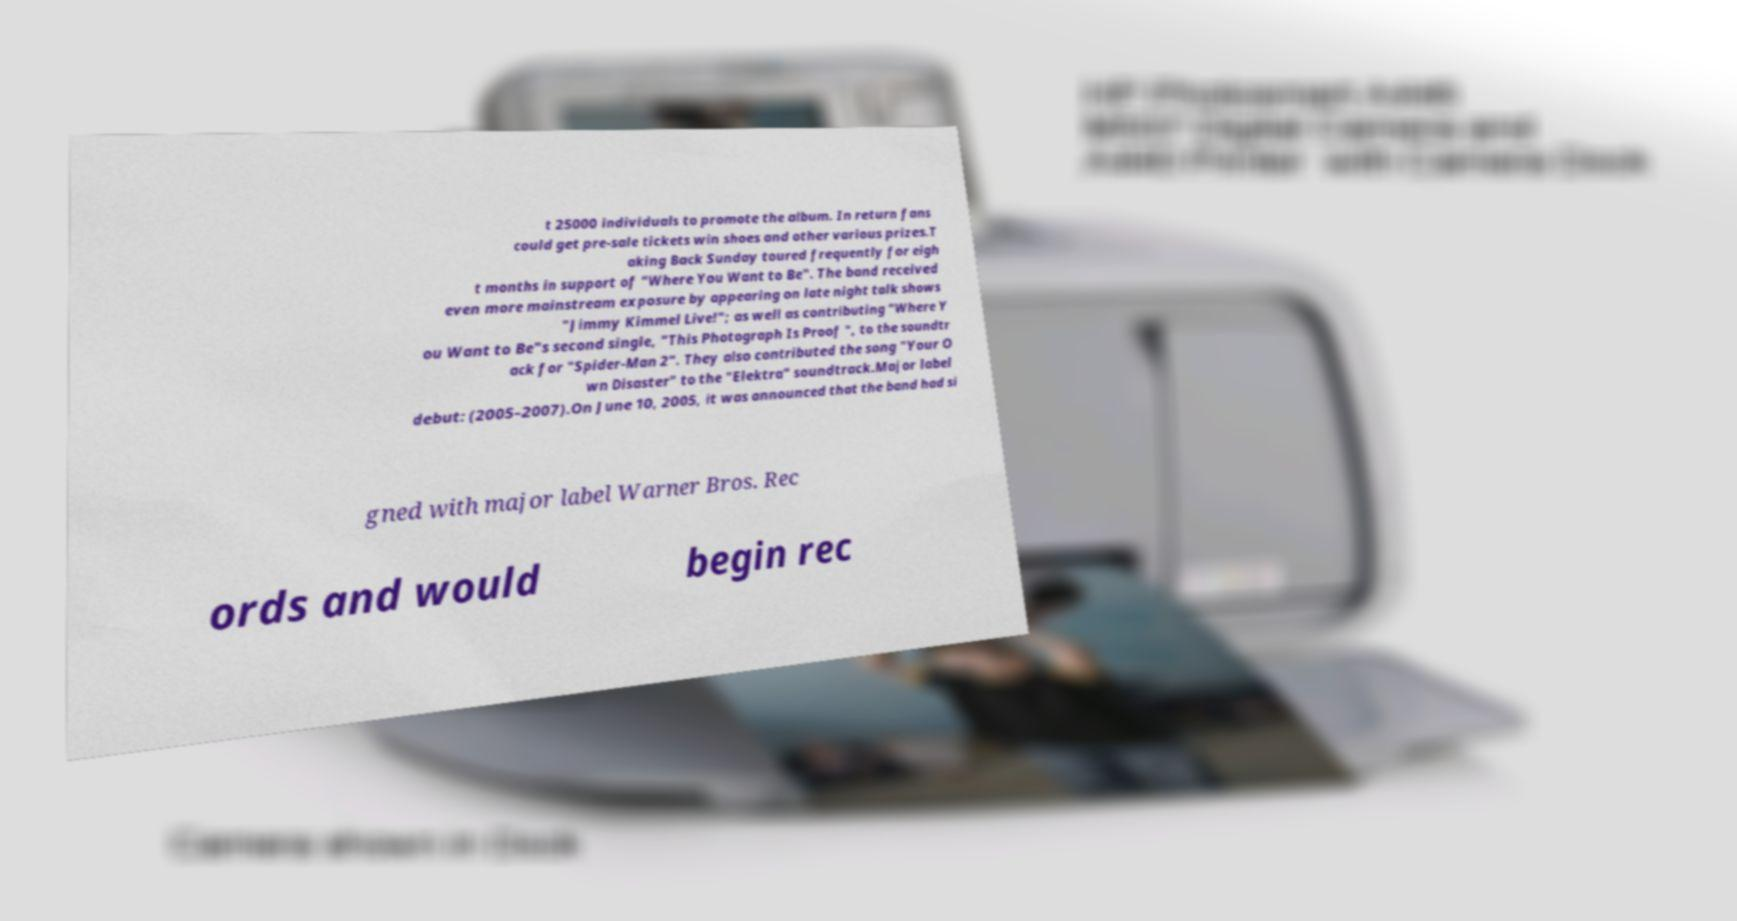Could you extract and type out the text from this image? t 25000 individuals to promote the album. In return fans could get pre-sale tickets win shoes and other various prizes.T aking Back Sunday toured frequently for eigh t months in support of "Where You Want to Be". The band received even more mainstream exposure by appearing on late night talk shows "Jimmy Kimmel Live!"; as well as contributing "Where Y ou Want to Be"s second single, "This Photograph Is Proof ", to the soundtr ack for "Spider-Man 2". They also contributed the song "Your O wn Disaster" to the "Elektra" soundtrack.Major label debut: (2005–2007).On June 10, 2005, it was announced that the band had si gned with major label Warner Bros. Rec ords and would begin rec 